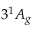<formula> <loc_0><loc_0><loc_500><loc_500>3 ^ { 1 } A _ { g }</formula> 